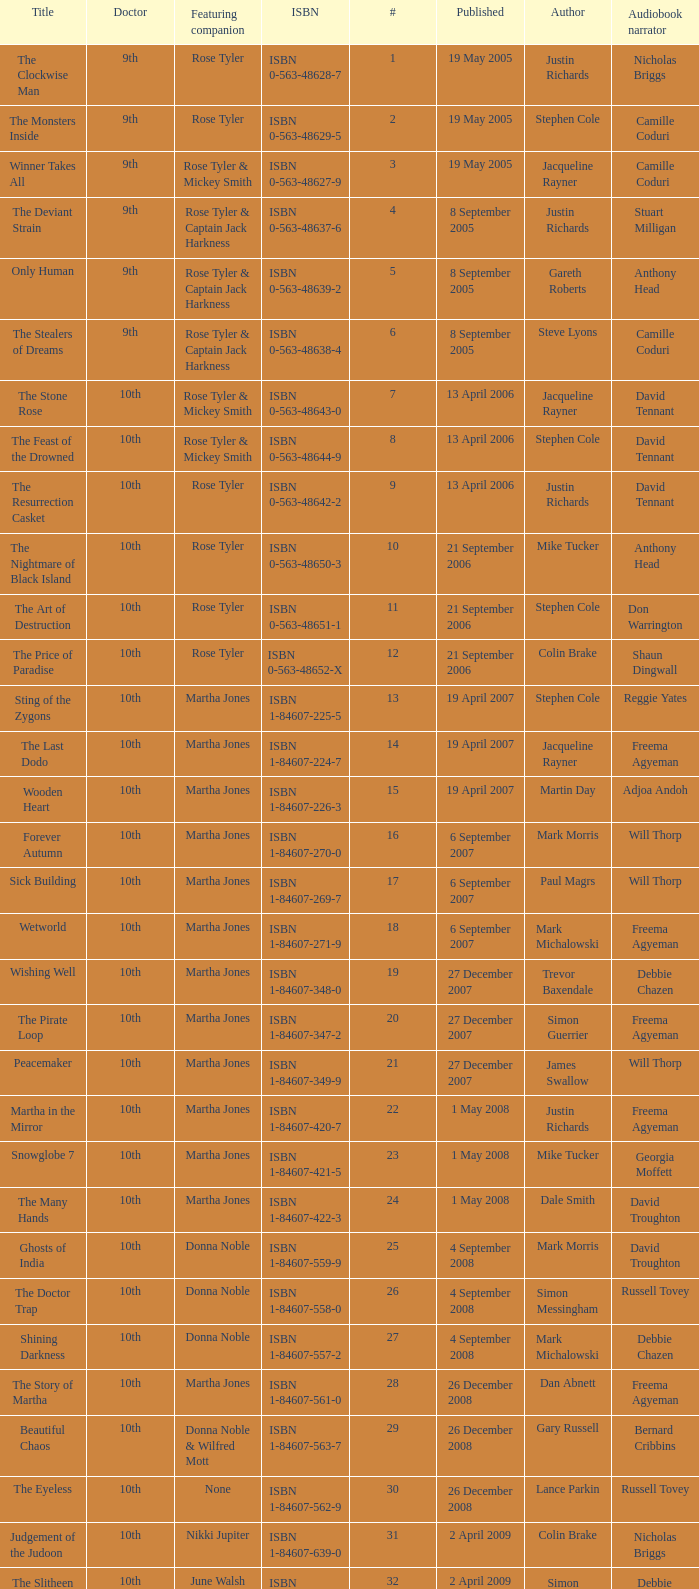What is the title of ISBN 1-84990-243-7? The Silent Stars Go By. 